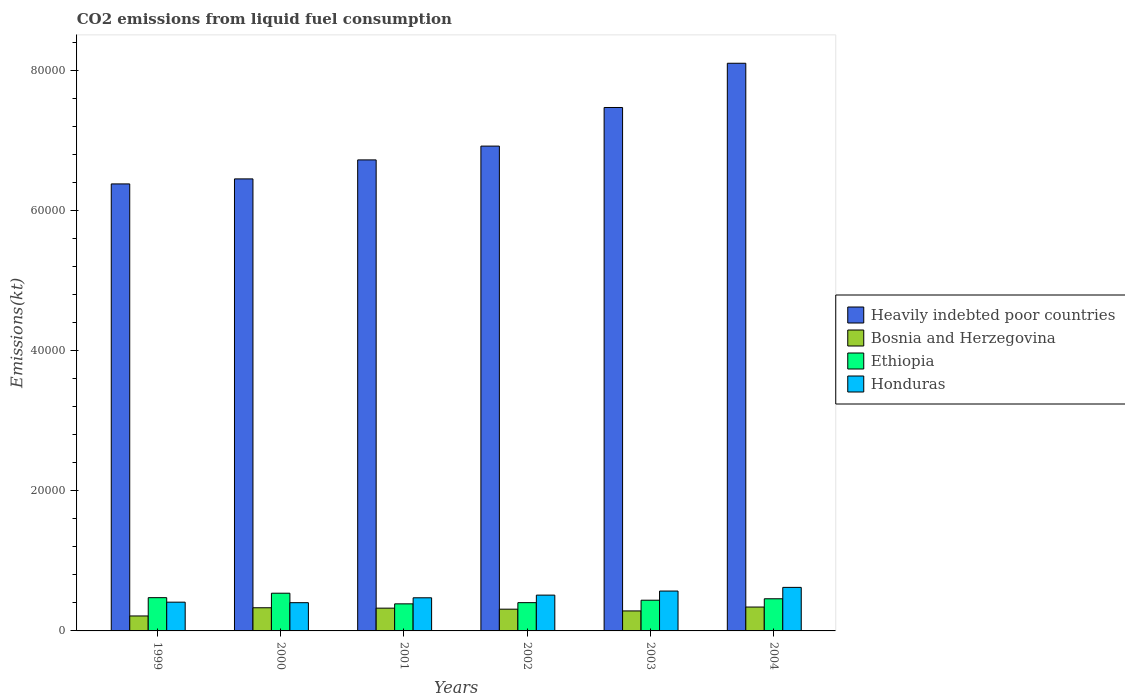How many different coloured bars are there?
Offer a terse response. 4. How many groups of bars are there?
Keep it short and to the point. 6. Are the number of bars on each tick of the X-axis equal?
Your answer should be compact. Yes. In how many cases, is the number of bars for a given year not equal to the number of legend labels?
Provide a short and direct response. 0. What is the amount of CO2 emitted in Ethiopia in 2002?
Offer a terse response. 4033.7. Across all years, what is the maximum amount of CO2 emitted in Heavily indebted poor countries?
Your answer should be very brief. 8.10e+04. Across all years, what is the minimum amount of CO2 emitted in Bosnia and Herzegovina?
Offer a terse response. 2134.19. In which year was the amount of CO2 emitted in Bosnia and Herzegovina minimum?
Ensure brevity in your answer.  1999. What is the total amount of CO2 emitted in Bosnia and Herzegovina in the graph?
Your answer should be compact. 1.80e+04. What is the difference between the amount of CO2 emitted in Ethiopia in 1999 and that in 2003?
Make the answer very short. 363.03. What is the difference between the amount of CO2 emitted in Bosnia and Herzegovina in 2003 and the amount of CO2 emitted in Heavily indebted poor countries in 2001?
Your response must be concise. -6.43e+04. What is the average amount of CO2 emitted in Honduras per year?
Offer a terse response. 4977.95. In the year 2002, what is the difference between the amount of CO2 emitted in Ethiopia and amount of CO2 emitted in Bosnia and Herzegovina?
Your answer should be very brief. 931.42. What is the ratio of the amount of CO2 emitted in Bosnia and Herzegovina in 2000 to that in 2003?
Make the answer very short. 1.16. What is the difference between the highest and the second highest amount of CO2 emitted in Ethiopia?
Keep it short and to the point. 634.39. What is the difference between the highest and the lowest amount of CO2 emitted in Bosnia and Herzegovina?
Your response must be concise. 1272.45. Is it the case that in every year, the sum of the amount of CO2 emitted in Bosnia and Herzegovina and amount of CO2 emitted in Honduras is greater than the sum of amount of CO2 emitted in Ethiopia and amount of CO2 emitted in Heavily indebted poor countries?
Keep it short and to the point. Yes. What does the 1st bar from the left in 2000 represents?
Give a very brief answer. Heavily indebted poor countries. What does the 3rd bar from the right in 2001 represents?
Make the answer very short. Bosnia and Herzegovina. Is it the case that in every year, the sum of the amount of CO2 emitted in Honduras and amount of CO2 emitted in Ethiopia is greater than the amount of CO2 emitted in Heavily indebted poor countries?
Make the answer very short. No. How many bars are there?
Offer a terse response. 24. Are all the bars in the graph horizontal?
Offer a very short reply. No. How many years are there in the graph?
Make the answer very short. 6. Does the graph contain any zero values?
Keep it short and to the point. No. Does the graph contain grids?
Your answer should be very brief. No. Where does the legend appear in the graph?
Make the answer very short. Center right. How are the legend labels stacked?
Your answer should be compact. Vertical. What is the title of the graph?
Offer a terse response. CO2 emissions from liquid fuel consumption. Does "French Polynesia" appear as one of the legend labels in the graph?
Make the answer very short. No. What is the label or title of the X-axis?
Your response must be concise. Years. What is the label or title of the Y-axis?
Give a very brief answer. Emissions(kt). What is the Emissions(kt) in Heavily indebted poor countries in 1999?
Ensure brevity in your answer.  6.38e+04. What is the Emissions(kt) in Bosnia and Herzegovina in 1999?
Your response must be concise. 2134.19. What is the Emissions(kt) of Ethiopia in 1999?
Offer a very short reply. 4745.1. What is the Emissions(kt) of Honduras in 1999?
Ensure brevity in your answer.  4103.37. What is the Emissions(kt) of Heavily indebted poor countries in 2000?
Give a very brief answer. 6.45e+04. What is the Emissions(kt) of Bosnia and Herzegovina in 2000?
Make the answer very short. 3303.97. What is the Emissions(kt) of Ethiopia in 2000?
Provide a succinct answer. 5379.49. What is the Emissions(kt) in Honduras in 2000?
Offer a very short reply. 4030.03. What is the Emissions(kt) in Heavily indebted poor countries in 2001?
Offer a terse response. 6.72e+04. What is the Emissions(kt) of Bosnia and Herzegovina in 2001?
Make the answer very short. 3248.96. What is the Emissions(kt) of Ethiopia in 2001?
Offer a very short reply. 3861.35. What is the Emissions(kt) of Honduras in 2001?
Your response must be concise. 4726.76. What is the Emissions(kt) of Heavily indebted poor countries in 2002?
Your response must be concise. 6.92e+04. What is the Emissions(kt) in Bosnia and Herzegovina in 2002?
Your answer should be compact. 3102.28. What is the Emissions(kt) of Ethiopia in 2002?
Provide a short and direct response. 4033.7. What is the Emissions(kt) in Honduras in 2002?
Your response must be concise. 5108.13. What is the Emissions(kt) in Heavily indebted poor countries in 2003?
Offer a terse response. 7.47e+04. What is the Emissions(kt) in Bosnia and Herzegovina in 2003?
Provide a short and direct response. 2852.93. What is the Emissions(kt) of Ethiopia in 2003?
Offer a very short reply. 4382.06. What is the Emissions(kt) of Honduras in 2003?
Your response must be concise. 5687.52. What is the Emissions(kt) of Heavily indebted poor countries in 2004?
Offer a very short reply. 8.10e+04. What is the Emissions(kt) in Bosnia and Herzegovina in 2004?
Provide a short and direct response. 3406.64. What is the Emissions(kt) of Ethiopia in 2004?
Keep it short and to the point. 4587.42. What is the Emissions(kt) of Honduras in 2004?
Keep it short and to the point. 6211.9. Across all years, what is the maximum Emissions(kt) in Heavily indebted poor countries?
Offer a very short reply. 8.10e+04. Across all years, what is the maximum Emissions(kt) in Bosnia and Herzegovina?
Provide a succinct answer. 3406.64. Across all years, what is the maximum Emissions(kt) of Ethiopia?
Your answer should be very brief. 5379.49. Across all years, what is the maximum Emissions(kt) in Honduras?
Keep it short and to the point. 6211.9. Across all years, what is the minimum Emissions(kt) in Heavily indebted poor countries?
Give a very brief answer. 6.38e+04. Across all years, what is the minimum Emissions(kt) of Bosnia and Herzegovina?
Your answer should be compact. 2134.19. Across all years, what is the minimum Emissions(kt) of Ethiopia?
Your response must be concise. 3861.35. Across all years, what is the minimum Emissions(kt) of Honduras?
Ensure brevity in your answer.  4030.03. What is the total Emissions(kt) in Heavily indebted poor countries in the graph?
Offer a very short reply. 4.20e+05. What is the total Emissions(kt) in Bosnia and Herzegovina in the graph?
Make the answer very short. 1.80e+04. What is the total Emissions(kt) in Ethiopia in the graph?
Your answer should be very brief. 2.70e+04. What is the total Emissions(kt) in Honduras in the graph?
Your answer should be compact. 2.99e+04. What is the difference between the Emissions(kt) in Heavily indebted poor countries in 1999 and that in 2000?
Your answer should be compact. -717.15. What is the difference between the Emissions(kt) of Bosnia and Herzegovina in 1999 and that in 2000?
Provide a succinct answer. -1169.77. What is the difference between the Emissions(kt) in Ethiopia in 1999 and that in 2000?
Your answer should be compact. -634.39. What is the difference between the Emissions(kt) of Honduras in 1999 and that in 2000?
Make the answer very short. 73.34. What is the difference between the Emissions(kt) in Heavily indebted poor countries in 1999 and that in 2001?
Give a very brief answer. -3427.06. What is the difference between the Emissions(kt) in Bosnia and Herzegovina in 1999 and that in 2001?
Your answer should be compact. -1114.77. What is the difference between the Emissions(kt) of Ethiopia in 1999 and that in 2001?
Your response must be concise. 883.75. What is the difference between the Emissions(kt) of Honduras in 1999 and that in 2001?
Provide a short and direct response. -623.39. What is the difference between the Emissions(kt) of Heavily indebted poor countries in 1999 and that in 2002?
Keep it short and to the point. -5396.24. What is the difference between the Emissions(kt) in Bosnia and Herzegovina in 1999 and that in 2002?
Your answer should be very brief. -968.09. What is the difference between the Emissions(kt) of Ethiopia in 1999 and that in 2002?
Provide a succinct answer. 711.4. What is the difference between the Emissions(kt) of Honduras in 1999 and that in 2002?
Your response must be concise. -1004.76. What is the difference between the Emissions(kt) of Heavily indebted poor countries in 1999 and that in 2003?
Offer a terse response. -1.09e+04. What is the difference between the Emissions(kt) of Bosnia and Herzegovina in 1999 and that in 2003?
Keep it short and to the point. -718.73. What is the difference between the Emissions(kt) in Ethiopia in 1999 and that in 2003?
Offer a very short reply. 363.03. What is the difference between the Emissions(kt) in Honduras in 1999 and that in 2003?
Offer a terse response. -1584.14. What is the difference between the Emissions(kt) in Heavily indebted poor countries in 1999 and that in 2004?
Your answer should be very brief. -1.72e+04. What is the difference between the Emissions(kt) of Bosnia and Herzegovina in 1999 and that in 2004?
Make the answer very short. -1272.45. What is the difference between the Emissions(kt) in Ethiopia in 1999 and that in 2004?
Give a very brief answer. 157.68. What is the difference between the Emissions(kt) of Honduras in 1999 and that in 2004?
Give a very brief answer. -2108.53. What is the difference between the Emissions(kt) in Heavily indebted poor countries in 2000 and that in 2001?
Offer a terse response. -2709.91. What is the difference between the Emissions(kt) of Bosnia and Herzegovina in 2000 and that in 2001?
Offer a very short reply. 55.01. What is the difference between the Emissions(kt) in Ethiopia in 2000 and that in 2001?
Make the answer very short. 1518.14. What is the difference between the Emissions(kt) in Honduras in 2000 and that in 2001?
Offer a very short reply. -696.73. What is the difference between the Emissions(kt) in Heavily indebted poor countries in 2000 and that in 2002?
Give a very brief answer. -4679.09. What is the difference between the Emissions(kt) of Bosnia and Herzegovina in 2000 and that in 2002?
Offer a terse response. 201.69. What is the difference between the Emissions(kt) in Ethiopia in 2000 and that in 2002?
Make the answer very short. 1345.79. What is the difference between the Emissions(kt) of Honduras in 2000 and that in 2002?
Ensure brevity in your answer.  -1078.1. What is the difference between the Emissions(kt) in Heavily indebted poor countries in 2000 and that in 2003?
Ensure brevity in your answer.  -1.02e+04. What is the difference between the Emissions(kt) in Bosnia and Herzegovina in 2000 and that in 2003?
Ensure brevity in your answer.  451.04. What is the difference between the Emissions(kt) in Ethiopia in 2000 and that in 2003?
Your response must be concise. 997.42. What is the difference between the Emissions(kt) of Honduras in 2000 and that in 2003?
Your answer should be compact. -1657.48. What is the difference between the Emissions(kt) of Heavily indebted poor countries in 2000 and that in 2004?
Offer a very short reply. -1.65e+04. What is the difference between the Emissions(kt) of Bosnia and Herzegovina in 2000 and that in 2004?
Your answer should be compact. -102.68. What is the difference between the Emissions(kt) in Ethiopia in 2000 and that in 2004?
Offer a very short reply. 792.07. What is the difference between the Emissions(kt) of Honduras in 2000 and that in 2004?
Make the answer very short. -2181.86. What is the difference between the Emissions(kt) in Heavily indebted poor countries in 2001 and that in 2002?
Offer a terse response. -1969.18. What is the difference between the Emissions(kt) of Bosnia and Herzegovina in 2001 and that in 2002?
Make the answer very short. 146.68. What is the difference between the Emissions(kt) in Ethiopia in 2001 and that in 2002?
Ensure brevity in your answer.  -172.35. What is the difference between the Emissions(kt) of Honduras in 2001 and that in 2002?
Keep it short and to the point. -381.37. What is the difference between the Emissions(kt) in Heavily indebted poor countries in 2001 and that in 2003?
Provide a short and direct response. -7477.01. What is the difference between the Emissions(kt) in Bosnia and Herzegovina in 2001 and that in 2003?
Keep it short and to the point. 396.04. What is the difference between the Emissions(kt) of Ethiopia in 2001 and that in 2003?
Ensure brevity in your answer.  -520.71. What is the difference between the Emissions(kt) in Honduras in 2001 and that in 2003?
Your response must be concise. -960.75. What is the difference between the Emissions(kt) of Heavily indebted poor countries in 2001 and that in 2004?
Give a very brief answer. -1.38e+04. What is the difference between the Emissions(kt) in Bosnia and Herzegovina in 2001 and that in 2004?
Offer a terse response. -157.68. What is the difference between the Emissions(kt) of Ethiopia in 2001 and that in 2004?
Provide a succinct answer. -726.07. What is the difference between the Emissions(kt) of Honduras in 2001 and that in 2004?
Give a very brief answer. -1485.13. What is the difference between the Emissions(kt) in Heavily indebted poor countries in 2002 and that in 2003?
Your answer should be very brief. -5507.83. What is the difference between the Emissions(kt) in Bosnia and Herzegovina in 2002 and that in 2003?
Provide a succinct answer. 249.36. What is the difference between the Emissions(kt) in Ethiopia in 2002 and that in 2003?
Your answer should be compact. -348.37. What is the difference between the Emissions(kt) of Honduras in 2002 and that in 2003?
Provide a short and direct response. -579.39. What is the difference between the Emissions(kt) of Heavily indebted poor countries in 2002 and that in 2004?
Provide a short and direct response. -1.18e+04. What is the difference between the Emissions(kt) of Bosnia and Herzegovina in 2002 and that in 2004?
Your answer should be very brief. -304.36. What is the difference between the Emissions(kt) in Ethiopia in 2002 and that in 2004?
Ensure brevity in your answer.  -553.72. What is the difference between the Emissions(kt) in Honduras in 2002 and that in 2004?
Keep it short and to the point. -1103.77. What is the difference between the Emissions(kt) in Heavily indebted poor countries in 2003 and that in 2004?
Give a very brief answer. -6310.91. What is the difference between the Emissions(kt) in Bosnia and Herzegovina in 2003 and that in 2004?
Provide a succinct answer. -553.72. What is the difference between the Emissions(kt) of Ethiopia in 2003 and that in 2004?
Your answer should be compact. -205.35. What is the difference between the Emissions(kt) of Honduras in 2003 and that in 2004?
Your answer should be very brief. -524.38. What is the difference between the Emissions(kt) of Heavily indebted poor countries in 1999 and the Emissions(kt) of Bosnia and Herzegovina in 2000?
Provide a succinct answer. 6.05e+04. What is the difference between the Emissions(kt) in Heavily indebted poor countries in 1999 and the Emissions(kt) in Ethiopia in 2000?
Your answer should be very brief. 5.84e+04. What is the difference between the Emissions(kt) in Heavily indebted poor countries in 1999 and the Emissions(kt) in Honduras in 2000?
Your response must be concise. 5.97e+04. What is the difference between the Emissions(kt) in Bosnia and Herzegovina in 1999 and the Emissions(kt) in Ethiopia in 2000?
Make the answer very short. -3245.3. What is the difference between the Emissions(kt) of Bosnia and Herzegovina in 1999 and the Emissions(kt) of Honduras in 2000?
Provide a short and direct response. -1895.84. What is the difference between the Emissions(kt) in Ethiopia in 1999 and the Emissions(kt) in Honduras in 2000?
Make the answer very short. 715.07. What is the difference between the Emissions(kt) in Heavily indebted poor countries in 1999 and the Emissions(kt) in Bosnia and Herzegovina in 2001?
Offer a very short reply. 6.05e+04. What is the difference between the Emissions(kt) in Heavily indebted poor countries in 1999 and the Emissions(kt) in Ethiopia in 2001?
Your response must be concise. 5.99e+04. What is the difference between the Emissions(kt) in Heavily indebted poor countries in 1999 and the Emissions(kt) in Honduras in 2001?
Ensure brevity in your answer.  5.90e+04. What is the difference between the Emissions(kt) in Bosnia and Herzegovina in 1999 and the Emissions(kt) in Ethiopia in 2001?
Make the answer very short. -1727.16. What is the difference between the Emissions(kt) in Bosnia and Herzegovina in 1999 and the Emissions(kt) in Honduras in 2001?
Your answer should be very brief. -2592.57. What is the difference between the Emissions(kt) of Ethiopia in 1999 and the Emissions(kt) of Honduras in 2001?
Your answer should be compact. 18.34. What is the difference between the Emissions(kt) of Heavily indebted poor countries in 1999 and the Emissions(kt) of Bosnia and Herzegovina in 2002?
Offer a terse response. 6.07e+04. What is the difference between the Emissions(kt) in Heavily indebted poor countries in 1999 and the Emissions(kt) in Ethiopia in 2002?
Provide a succinct answer. 5.97e+04. What is the difference between the Emissions(kt) of Heavily indebted poor countries in 1999 and the Emissions(kt) of Honduras in 2002?
Ensure brevity in your answer.  5.87e+04. What is the difference between the Emissions(kt) of Bosnia and Herzegovina in 1999 and the Emissions(kt) of Ethiopia in 2002?
Keep it short and to the point. -1899.51. What is the difference between the Emissions(kt) of Bosnia and Herzegovina in 1999 and the Emissions(kt) of Honduras in 2002?
Your answer should be compact. -2973.94. What is the difference between the Emissions(kt) of Ethiopia in 1999 and the Emissions(kt) of Honduras in 2002?
Offer a very short reply. -363.03. What is the difference between the Emissions(kt) of Heavily indebted poor countries in 1999 and the Emissions(kt) of Bosnia and Herzegovina in 2003?
Provide a succinct answer. 6.09e+04. What is the difference between the Emissions(kt) of Heavily indebted poor countries in 1999 and the Emissions(kt) of Ethiopia in 2003?
Keep it short and to the point. 5.94e+04. What is the difference between the Emissions(kt) in Heavily indebted poor countries in 1999 and the Emissions(kt) in Honduras in 2003?
Ensure brevity in your answer.  5.81e+04. What is the difference between the Emissions(kt) in Bosnia and Herzegovina in 1999 and the Emissions(kt) in Ethiopia in 2003?
Give a very brief answer. -2247.87. What is the difference between the Emissions(kt) in Bosnia and Herzegovina in 1999 and the Emissions(kt) in Honduras in 2003?
Provide a short and direct response. -3553.32. What is the difference between the Emissions(kt) in Ethiopia in 1999 and the Emissions(kt) in Honduras in 2003?
Your answer should be compact. -942.42. What is the difference between the Emissions(kt) in Heavily indebted poor countries in 1999 and the Emissions(kt) in Bosnia and Herzegovina in 2004?
Keep it short and to the point. 6.04e+04. What is the difference between the Emissions(kt) in Heavily indebted poor countries in 1999 and the Emissions(kt) in Ethiopia in 2004?
Your answer should be compact. 5.92e+04. What is the difference between the Emissions(kt) in Heavily indebted poor countries in 1999 and the Emissions(kt) in Honduras in 2004?
Your answer should be compact. 5.76e+04. What is the difference between the Emissions(kt) of Bosnia and Herzegovina in 1999 and the Emissions(kt) of Ethiopia in 2004?
Provide a succinct answer. -2453.22. What is the difference between the Emissions(kt) of Bosnia and Herzegovina in 1999 and the Emissions(kt) of Honduras in 2004?
Offer a very short reply. -4077.7. What is the difference between the Emissions(kt) of Ethiopia in 1999 and the Emissions(kt) of Honduras in 2004?
Provide a short and direct response. -1466.8. What is the difference between the Emissions(kt) of Heavily indebted poor countries in 2000 and the Emissions(kt) of Bosnia and Herzegovina in 2001?
Provide a succinct answer. 6.12e+04. What is the difference between the Emissions(kt) of Heavily indebted poor countries in 2000 and the Emissions(kt) of Ethiopia in 2001?
Your answer should be very brief. 6.06e+04. What is the difference between the Emissions(kt) of Heavily indebted poor countries in 2000 and the Emissions(kt) of Honduras in 2001?
Keep it short and to the point. 5.98e+04. What is the difference between the Emissions(kt) of Bosnia and Herzegovina in 2000 and the Emissions(kt) of Ethiopia in 2001?
Provide a short and direct response. -557.38. What is the difference between the Emissions(kt) of Bosnia and Herzegovina in 2000 and the Emissions(kt) of Honduras in 2001?
Make the answer very short. -1422.8. What is the difference between the Emissions(kt) of Ethiopia in 2000 and the Emissions(kt) of Honduras in 2001?
Your response must be concise. 652.73. What is the difference between the Emissions(kt) in Heavily indebted poor countries in 2000 and the Emissions(kt) in Bosnia and Herzegovina in 2002?
Your answer should be compact. 6.14e+04. What is the difference between the Emissions(kt) of Heavily indebted poor countries in 2000 and the Emissions(kt) of Ethiopia in 2002?
Offer a terse response. 6.05e+04. What is the difference between the Emissions(kt) in Heavily indebted poor countries in 2000 and the Emissions(kt) in Honduras in 2002?
Your answer should be compact. 5.94e+04. What is the difference between the Emissions(kt) in Bosnia and Herzegovina in 2000 and the Emissions(kt) in Ethiopia in 2002?
Ensure brevity in your answer.  -729.73. What is the difference between the Emissions(kt) of Bosnia and Herzegovina in 2000 and the Emissions(kt) of Honduras in 2002?
Offer a terse response. -1804.16. What is the difference between the Emissions(kt) in Ethiopia in 2000 and the Emissions(kt) in Honduras in 2002?
Provide a short and direct response. 271.36. What is the difference between the Emissions(kt) in Heavily indebted poor countries in 2000 and the Emissions(kt) in Bosnia and Herzegovina in 2003?
Ensure brevity in your answer.  6.16e+04. What is the difference between the Emissions(kt) of Heavily indebted poor countries in 2000 and the Emissions(kt) of Ethiopia in 2003?
Make the answer very short. 6.01e+04. What is the difference between the Emissions(kt) of Heavily indebted poor countries in 2000 and the Emissions(kt) of Honduras in 2003?
Ensure brevity in your answer.  5.88e+04. What is the difference between the Emissions(kt) of Bosnia and Herzegovina in 2000 and the Emissions(kt) of Ethiopia in 2003?
Ensure brevity in your answer.  -1078.1. What is the difference between the Emissions(kt) of Bosnia and Herzegovina in 2000 and the Emissions(kt) of Honduras in 2003?
Your response must be concise. -2383.55. What is the difference between the Emissions(kt) in Ethiopia in 2000 and the Emissions(kt) in Honduras in 2003?
Keep it short and to the point. -308.03. What is the difference between the Emissions(kt) of Heavily indebted poor countries in 2000 and the Emissions(kt) of Bosnia and Herzegovina in 2004?
Provide a succinct answer. 6.11e+04. What is the difference between the Emissions(kt) of Heavily indebted poor countries in 2000 and the Emissions(kt) of Ethiopia in 2004?
Your answer should be very brief. 5.99e+04. What is the difference between the Emissions(kt) of Heavily indebted poor countries in 2000 and the Emissions(kt) of Honduras in 2004?
Offer a very short reply. 5.83e+04. What is the difference between the Emissions(kt) in Bosnia and Herzegovina in 2000 and the Emissions(kt) in Ethiopia in 2004?
Provide a short and direct response. -1283.45. What is the difference between the Emissions(kt) of Bosnia and Herzegovina in 2000 and the Emissions(kt) of Honduras in 2004?
Your response must be concise. -2907.93. What is the difference between the Emissions(kt) of Ethiopia in 2000 and the Emissions(kt) of Honduras in 2004?
Give a very brief answer. -832.41. What is the difference between the Emissions(kt) of Heavily indebted poor countries in 2001 and the Emissions(kt) of Bosnia and Herzegovina in 2002?
Make the answer very short. 6.41e+04. What is the difference between the Emissions(kt) in Heavily indebted poor countries in 2001 and the Emissions(kt) in Ethiopia in 2002?
Ensure brevity in your answer.  6.32e+04. What is the difference between the Emissions(kt) of Heavily indebted poor countries in 2001 and the Emissions(kt) of Honduras in 2002?
Provide a short and direct response. 6.21e+04. What is the difference between the Emissions(kt) in Bosnia and Herzegovina in 2001 and the Emissions(kt) in Ethiopia in 2002?
Ensure brevity in your answer.  -784.74. What is the difference between the Emissions(kt) of Bosnia and Herzegovina in 2001 and the Emissions(kt) of Honduras in 2002?
Offer a very short reply. -1859.17. What is the difference between the Emissions(kt) in Ethiopia in 2001 and the Emissions(kt) in Honduras in 2002?
Offer a very short reply. -1246.78. What is the difference between the Emissions(kt) in Heavily indebted poor countries in 2001 and the Emissions(kt) in Bosnia and Herzegovina in 2003?
Keep it short and to the point. 6.43e+04. What is the difference between the Emissions(kt) in Heavily indebted poor countries in 2001 and the Emissions(kt) in Ethiopia in 2003?
Offer a very short reply. 6.28e+04. What is the difference between the Emissions(kt) of Heavily indebted poor countries in 2001 and the Emissions(kt) of Honduras in 2003?
Offer a very short reply. 6.15e+04. What is the difference between the Emissions(kt) in Bosnia and Herzegovina in 2001 and the Emissions(kt) in Ethiopia in 2003?
Ensure brevity in your answer.  -1133.1. What is the difference between the Emissions(kt) of Bosnia and Herzegovina in 2001 and the Emissions(kt) of Honduras in 2003?
Make the answer very short. -2438.55. What is the difference between the Emissions(kt) in Ethiopia in 2001 and the Emissions(kt) in Honduras in 2003?
Give a very brief answer. -1826.17. What is the difference between the Emissions(kt) of Heavily indebted poor countries in 2001 and the Emissions(kt) of Bosnia and Herzegovina in 2004?
Your answer should be compact. 6.38e+04. What is the difference between the Emissions(kt) of Heavily indebted poor countries in 2001 and the Emissions(kt) of Ethiopia in 2004?
Provide a succinct answer. 6.26e+04. What is the difference between the Emissions(kt) of Heavily indebted poor countries in 2001 and the Emissions(kt) of Honduras in 2004?
Give a very brief answer. 6.10e+04. What is the difference between the Emissions(kt) in Bosnia and Herzegovina in 2001 and the Emissions(kt) in Ethiopia in 2004?
Make the answer very short. -1338.45. What is the difference between the Emissions(kt) in Bosnia and Herzegovina in 2001 and the Emissions(kt) in Honduras in 2004?
Keep it short and to the point. -2962.94. What is the difference between the Emissions(kt) of Ethiopia in 2001 and the Emissions(kt) of Honduras in 2004?
Your answer should be compact. -2350.55. What is the difference between the Emissions(kt) in Heavily indebted poor countries in 2002 and the Emissions(kt) in Bosnia and Herzegovina in 2003?
Provide a short and direct response. 6.63e+04. What is the difference between the Emissions(kt) in Heavily indebted poor countries in 2002 and the Emissions(kt) in Ethiopia in 2003?
Your answer should be very brief. 6.48e+04. What is the difference between the Emissions(kt) of Heavily indebted poor countries in 2002 and the Emissions(kt) of Honduras in 2003?
Give a very brief answer. 6.35e+04. What is the difference between the Emissions(kt) of Bosnia and Herzegovina in 2002 and the Emissions(kt) of Ethiopia in 2003?
Provide a short and direct response. -1279.78. What is the difference between the Emissions(kt) in Bosnia and Herzegovina in 2002 and the Emissions(kt) in Honduras in 2003?
Ensure brevity in your answer.  -2585.24. What is the difference between the Emissions(kt) of Ethiopia in 2002 and the Emissions(kt) of Honduras in 2003?
Keep it short and to the point. -1653.82. What is the difference between the Emissions(kt) of Heavily indebted poor countries in 2002 and the Emissions(kt) of Bosnia and Herzegovina in 2004?
Provide a short and direct response. 6.58e+04. What is the difference between the Emissions(kt) of Heavily indebted poor countries in 2002 and the Emissions(kt) of Ethiopia in 2004?
Provide a short and direct response. 6.46e+04. What is the difference between the Emissions(kt) in Heavily indebted poor countries in 2002 and the Emissions(kt) in Honduras in 2004?
Your answer should be compact. 6.30e+04. What is the difference between the Emissions(kt) of Bosnia and Herzegovina in 2002 and the Emissions(kt) of Ethiopia in 2004?
Ensure brevity in your answer.  -1485.13. What is the difference between the Emissions(kt) of Bosnia and Herzegovina in 2002 and the Emissions(kt) of Honduras in 2004?
Your answer should be compact. -3109.62. What is the difference between the Emissions(kt) in Ethiopia in 2002 and the Emissions(kt) in Honduras in 2004?
Your answer should be very brief. -2178.2. What is the difference between the Emissions(kt) of Heavily indebted poor countries in 2003 and the Emissions(kt) of Bosnia and Herzegovina in 2004?
Your response must be concise. 7.13e+04. What is the difference between the Emissions(kt) in Heavily indebted poor countries in 2003 and the Emissions(kt) in Ethiopia in 2004?
Offer a very short reply. 7.01e+04. What is the difference between the Emissions(kt) of Heavily indebted poor countries in 2003 and the Emissions(kt) of Honduras in 2004?
Offer a terse response. 6.85e+04. What is the difference between the Emissions(kt) of Bosnia and Herzegovina in 2003 and the Emissions(kt) of Ethiopia in 2004?
Make the answer very short. -1734.49. What is the difference between the Emissions(kt) of Bosnia and Herzegovina in 2003 and the Emissions(kt) of Honduras in 2004?
Offer a terse response. -3358.97. What is the difference between the Emissions(kt) of Ethiopia in 2003 and the Emissions(kt) of Honduras in 2004?
Make the answer very short. -1829.83. What is the average Emissions(kt) in Heavily indebted poor countries per year?
Provide a succinct answer. 7.01e+04. What is the average Emissions(kt) of Bosnia and Herzegovina per year?
Offer a very short reply. 3008.16. What is the average Emissions(kt) of Ethiopia per year?
Your answer should be very brief. 4498.19. What is the average Emissions(kt) of Honduras per year?
Offer a very short reply. 4977.95. In the year 1999, what is the difference between the Emissions(kt) of Heavily indebted poor countries and Emissions(kt) of Bosnia and Herzegovina?
Give a very brief answer. 6.16e+04. In the year 1999, what is the difference between the Emissions(kt) of Heavily indebted poor countries and Emissions(kt) of Ethiopia?
Your response must be concise. 5.90e+04. In the year 1999, what is the difference between the Emissions(kt) of Heavily indebted poor countries and Emissions(kt) of Honduras?
Give a very brief answer. 5.97e+04. In the year 1999, what is the difference between the Emissions(kt) in Bosnia and Herzegovina and Emissions(kt) in Ethiopia?
Provide a succinct answer. -2610.9. In the year 1999, what is the difference between the Emissions(kt) in Bosnia and Herzegovina and Emissions(kt) in Honduras?
Your response must be concise. -1969.18. In the year 1999, what is the difference between the Emissions(kt) in Ethiopia and Emissions(kt) in Honduras?
Keep it short and to the point. 641.73. In the year 2000, what is the difference between the Emissions(kt) in Heavily indebted poor countries and Emissions(kt) in Bosnia and Herzegovina?
Ensure brevity in your answer.  6.12e+04. In the year 2000, what is the difference between the Emissions(kt) in Heavily indebted poor countries and Emissions(kt) in Ethiopia?
Keep it short and to the point. 5.91e+04. In the year 2000, what is the difference between the Emissions(kt) of Heavily indebted poor countries and Emissions(kt) of Honduras?
Provide a succinct answer. 6.05e+04. In the year 2000, what is the difference between the Emissions(kt) in Bosnia and Herzegovina and Emissions(kt) in Ethiopia?
Make the answer very short. -2075.52. In the year 2000, what is the difference between the Emissions(kt) of Bosnia and Herzegovina and Emissions(kt) of Honduras?
Offer a terse response. -726.07. In the year 2000, what is the difference between the Emissions(kt) in Ethiopia and Emissions(kt) in Honduras?
Provide a succinct answer. 1349.46. In the year 2001, what is the difference between the Emissions(kt) in Heavily indebted poor countries and Emissions(kt) in Bosnia and Herzegovina?
Your response must be concise. 6.40e+04. In the year 2001, what is the difference between the Emissions(kt) in Heavily indebted poor countries and Emissions(kt) in Ethiopia?
Offer a terse response. 6.33e+04. In the year 2001, what is the difference between the Emissions(kt) of Heavily indebted poor countries and Emissions(kt) of Honduras?
Ensure brevity in your answer.  6.25e+04. In the year 2001, what is the difference between the Emissions(kt) of Bosnia and Herzegovina and Emissions(kt) of Ethiopia?
Make the answer very short. -612.39. In the year 2001, what is the difference between the Emissions(kt) in Bosnia and Herzegovina and Emissions(kt) in Honduras?
Make the answer very short. -1477.8. In the year 2001, what is the difference between the Emissions(kt) in Ethiopia and Emissions(kt) in Honduras?
Give a very brief answer. -865.41. In the year 2002, what is the difference between the Emissions(kt) in Heavily indebted poor countries and Emissions(kt) in Bosnia and Herzegovina?
Ensure brevity in your answer.  6.61e+04. In the year 2002, what is the difference between the Emissions(kt) of Heavily indebted poor countries and Emissions(kt) of Ethiopia?
Give a very brief answer. 6.51e+04. In the year 2002, what is the difference between the Emissions(kt) in Heavily indebted poor countries and Emissions(kt) in Honduras?
Your answer should be very brief. 6.41e+04. In the year 2002, what is the difference between the Emissions(kt) in Bosnia and Herzegovina and Emissions(kt) in Ethiopia?
Your answer should be compact. -931.42. In the year 2002, what is the difference between the Emissions(kt) of Bosnia and Herzegovina and Emissions(kt) of Honduras?
Ensure brevity in your answer.  -2005.85. In the year 2002, what is the difference between the Emissions(kt) of Ethiopia and Emissions(kt) of Honduras?
Make the answer very short. -1074.43. In the year 2003, what is the difference between the Emissions(kt) of Heavily indebted poor countries and Emissions(kt) of Bosnia and Herzegovina?
Keep it short and to the point. 7.18e+04. In the year 2003, what is the difference between the Emissions(kt) in Heavily indebted poor countries and Emissions(kt) in Ethiopia?
Offer a terse response. 7.03e+04. In the year 2003, what is the difference between the Emissions(kt) in Heavily indebted poor countries and Emissions(kt) in Honduras?
Ensure brevity in your answer.  6.90e+04. In the year 2003, what is the difference between the Emissions(kt) of Bosnia and Herzegovina and Emissions(kt) of Ethiopia?
Make the answer very short. -1529.14. In the year 2003, what is the difference between the Emissions(kt) of Bosnia and Herzegovina and Emissions(kt) of Honduras?
Provide a succinct answer. -2834.59. In the year 2003, what is the difference between the Emissions(kt) in Ethiopia and Emissions(kt) in Honduras?
Your answer should be very brief. -1305.45. In the year 2004, what is the difference between the Emissions(kt) of Heavily indebted poor countries and Emissions(kt) of Bosnia and Herzegovina?
Ensure brevity in your answer.  7.76e+04. In the year 2004, what is the difference between the Emissions(kt) in Heavily indebted poor countries and Emissions(kt) in Ethiopia?
Make the answer very short. 7.64e+04. In the year 2004, what is the difference between the Emissions(kt) in Heavily indebted poor countries and Emissions(kt) in Honduras?
Make the answer very short. 7.48e+04. In the year 2004, what is the difference between the Emissions(kt) in Bosnia and Herzegovina and Emissions(kt) in Ethiopia?
Provide a succinct answer. -1180.77. In the year 2004, what is the difference between the Emissions(kt) in Bosnia and Herzegovina and Emissions(kt) in Honduras?
Offer a very short reply. -2805.26. In the year 2004, what is the difference between the Emissions(kt) in Ethiopia and Emissions(kt) in Honduras?
Provide a succinct answer. -1624.48. What is the ratio of the Emissions(kt) of Heavily indebted poor countries in 1999 to that in 2000?
Keep it short and to the point. 0.99. What is the ratio of the Emissions(kt) of Bosnia and Herzegovina in 1999 to that in 2000?
Provide a succinct answer. 0.65. What is the ratio of the Emissions(kt) in Ethiopia in 1999 to that in 2000?
Offer a very short reply. 0.88. What is the ratio of the Emissions(kt) of Honduras in 1999 to that in 2000?
Your answer should be compact. 1.02. What is the ratio of the Emissions(kt) of Heavily indebted poor countries in 1999 to that in 2001?
Give a very brief answer. 0.95. What is the ratio of the Emissions(kt) in Bosnia and Herzegovina in 1999 to that in 2001?
Your answer should be compact. 0.66. What is the ratio of the Emissions(kt) of Ethiopia in 1999 to that in 2001?
Provide a succinct answer. 1.23. What is the ratio of the Emissions(kt) of Honduras in 1999 to that in 2001?
Keep it short and to the point. 0.87. What is the ratio of the Emissions(kt) in Heavily indebted poor countries in 1999 to that in 2002?
Give a very brief answer. 0.92. What is the ratio of the Emissions(kt) of Bosnia and Herzegovina in 1999 to that in 2002?
Ensure brevity in your answer.  0.69. What is the ratio of the Emissions(kt) of Ethiopia in 1999 to that in 2002?
Offer a terse response. 1.18. What is the ratio of the Emissions(kt) in Honduras in 1999 to that in 2002?
Your response must be concise. 0.8. What is the ratio of the Emissions(kt) of Heavily indebted poor countries in 1999 to that in 2003?
Your answer should be very brief. 0.85. What is the ratio of the Emissions(kt) of Bosnia and Herzegovina in 1999 to that in 2003?
Keep it short and to the point. 0.75. What is the ratio of the Emissions(kt) in Ethiopia in 1999 to that in 2003?
Your response must be concise. 1.08. What is the ratio of the Emissions(kt) of Honduras in 1999 to that in 2003?
Provide a short and direct response. 0.72. What is the ratio of the Emissions(kt) in Heavily indebted poor countries in 1999 to that in 2004?
Make the answer very short. 0.79. What is the ratio of the Emissions(kt) in Bosnia and Herzegovina in 1999 to that in 2004?
Provide a short and direct response. 0.63. What is the ratio of the Emissions(kt) of Ethiopia in 1999 to that in 2004?
Your response must be concise. 1.03. What is the ratio of the Emissions(kt) of Honduras in 1999 to that in 2004?
Give a very brief answer. 0.66. What is the ratio of the Emissions(kt) of Heavily indebted poor countries in 2000 to that in 2001?
Your answer should be compact. 0.96. What is the ratio of the Emissions(kt) in Bosnia and Herzegovina in 2000 to that in 2001?
Make the answer very short. 1.02. What is the ratio of the Emissions(kt) of Ethiopia in 2000 to that in 2001?
Provide a succinct answer. 1.39. What is the ratio of the Emissions(kt) of Honduras in 2000 to that in 2001?
Provide a short and direct response. 0.85. What is the ratio of the Emissions(kt) in Heavily indebted poor countries in 2000 to that in 2002?
Offer a very short reply. 0.93. What is the ratio of the Emissions(kt) of Bosnia and Herzegovina in 2000 to that in 2002?
Keep it short and to the point. 1.06. What is the ratio of the Emissions(kt) of Ethiopia in 2000 to that in 2002?
Provide a succinct answer. 1.33. What is the ratio of the Emissions(kt) in Honduras in 2000 to that in 2002?
Make the answer very short. 0.79. What is the ratio of the Emissions(kt) in Heavily indebted poor countries in 2000 to that in 2003?
Provide a succinct answer. 0.86. What is the ratio of the Emissions(kt) of Bosnia and Herzegovina in 2000 to that in 2003?
Your answer should be compact. 1.16. What is the ratio of the Emissions(kt) in Ethiopia in 2000 to that in 2003?
Offer a very short reply. 1.23. What is the ratio of the Emissions(kt) in Honduras in 2000 to that in 2003?
Provide a short and direct response. 0.71. What is the ratio of the Emissions(kt) in Heavily indebted poor countries in 2000 to that in 2004?
Ensure brevity in your answer.  0.8. What is the ratio of the Emissions(kt) of Bosnia and Herzegovina in 2000 to that in 2004?
Provide a short and direct response. 0.97. What is the ratio of the Emissions(kt) of Ethiopia in 2000 to that in 2004?
Ensure brevity in your answer.  1.17. What is the ratio of the Emissions(kt) in Honduras in 2000 to that in 2004?
Provide a short and direct response. 0.65. What is the ratio of the Emissions(kt) of Heavily indebted poor countries in 2001 to that in 2002?
Offer a terse response. 0.97. What is the ratio of the Emissions(kt) in Bosnia and Herzegovina in 2001 to that in 2002?
Provide a succinct answer. 1.05. What is the ratio of the Emissions(kt) of Ethiopia in 2001 to that in 2002?
Give a very brief answer. 0.96. What is the ratio of the Emissions(kt) in Honduras in 2001 to that in 2002?
Offer a terse response. 0.93. What is the ratio of the Emissions(kt) in Heavily indebted poor countries in 2001 to that in 2003?
Your answer should be very brief. 0.9. What is the ratio of the Emissions(kt) of Bosnia and Herzegovina in 2001 to that in 2003?
Keep it short and to the point. 1.14. What is the ratio of the Emissions(kt) in Ethiopia in 2001 to that in 2003?
Offer a very short reply. 0.88. What is the ratio of the Emissions(kt) of Honduras in 2001 to that in 2003?
Ensure brevity in your answer.  0.83. What is the ratio of the Emissions(kt) in Heavily indebted poor countries in 2001 to that in 2004?
Give a very brief answer. 0.83. What is the ratio of the Emissions(kt) of Bosnia and Herzegovina in 2001 to that in 2004?
Provide a succinct answer. 0.95. What is the ratio of the Emissions(kt) in Ethiopia in 2001 to that in 2004?
Your response must be concise. 0.84. What is the ratio of the Emissions(kt) of Honduras in 2001 to that in 2004?
Give a very brief answer. 0.76. What is the ratio of the Emissions(kt) of Heavily indebted poor countries in 2002 to that in 2003?
Offer a very short reply. 0.93. What is the ratio of the Emissions(kt) in Bosnia and Herzegovina in 2002 to that in 2003?
Provide a short and direct response. 1.09. What is the ratio of the Emissions(kt) in Ethiopia in 2002 to that in 2003?
Your response must be concise. 0.92. What is the ratio of the Emissions(kt) in Honduras in 2002 to that in 2003?
Offer a very short reply. 0.9. What is the ratio of the Emissions(kt) in Heavily indebted poor countries in 2002 to that in 2004?
Ensure brevity in your answer.  0.85. What is the ratio of the Emissions(kt) of Bosnia and Herzegovina in 2002 to that in 2004?
Give a very brief answer. 0.91. What is the ratio of the Emissions(kt) of Ethiopia in 2002 to that in 2004?
Keep it short and to the point. 0.88. What is the ratio of the Emissions(kt) of Honduras in 2002 to that in 2004?
Give a very brief answer. 0.82. What is the ratio of the Emissions(kt) in Heavily indebted poor countries in 2003 to that in 2004?
Your response must be concise. 0.92. What is the ratio of the Emissions(kt) of Bosnia and Herzegovina in 2003 to that in 2004?
Offer a terse response. 0.84. What is the ratio of the Emissions(kt) of Ethiopia in 2003 to that in 2004?
Keep it short and to the point. 0.96. What is the ratio of the Emissions(kt) of Honduras in 2003 to that in 2004?
Offer a terse response. 0.92. What is the difference between the highest and the second highest Emissions(kt) in Heavily indebted poor countries?
Ensure brevity in your answer.  6310.91. What is the difference between the highest and the second highest Emissions(kt) in Bosnia and Herzegovina?
Offer a very short reply. 102.68. What is the difference between the highest and the second highest Emissions(kt) in Ethiopia?
Make the answer very short. 634.39. What is the difference between the highest and the second highest Emissions(kt) of Honduras?
Your response must be concise. 524.38. What is the difference between the highest and the lowest Emissions(kt) in Heavily indebted poor countries?
Keep it short and to the point. 1.72e+04. What is the difference between the highest and the lowest Emissions(kt) of Bosnia and Herzegovina?
Ensure brevity in your answer.  1272.45. What is the difference between the highest and the lowest Emissions(kt) of Ethiopia?
Your response must be concise. 1518.14. What is the difference between the highest and the lowest Emissions(kt) in Honduras?
Your answer should be very brief. 2181.86. 